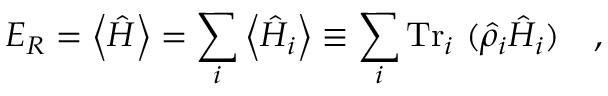Convert formula to latex. <formula><loc_0><loc_0><loc_500><loc_500>E _ { R } = \left \langle \hat { H } \right \rangle = \sum _ { i } \left \langle \hat { H } _ { i } \right \rangle \equiv \sum _ { i } T r _ { i } ( \hat { \rho } _ { i } \hat { H } _ { i } ) ,</formula> 